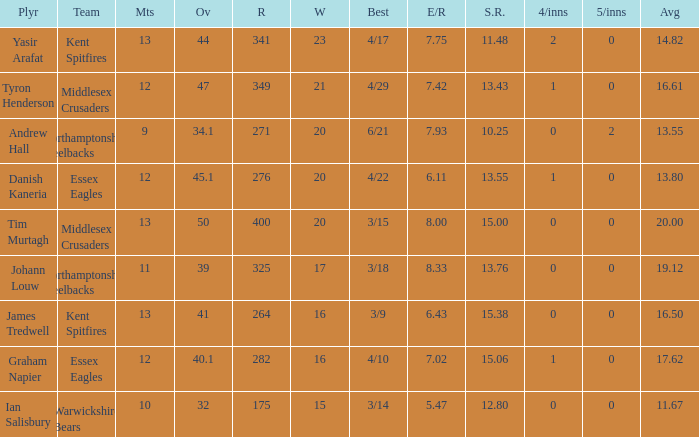Name the matches for wickets 17 11.0. 